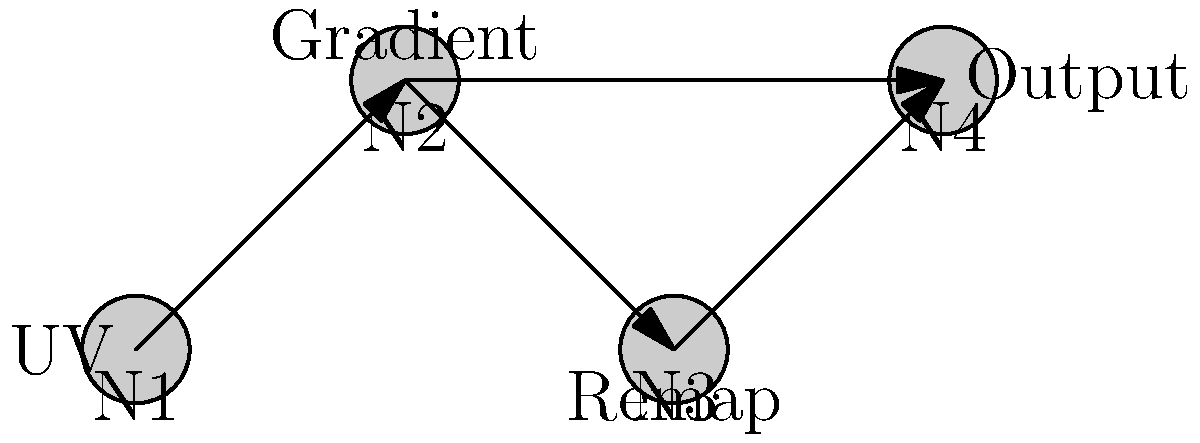In the shader graph shown above, which node configuration would be most suitable for creating a radial gradient effect that transitions smoothly from the center to the edges of a texture? Explain the purpose of each node in achieving this effect. To create a radial gradient effect that transitions smoothly from the center to the edges of a texture, we can use the following node configuration:

1. UV Node (N1):
   - Provides the UV coordinates of the texture.
   - Essential for determining the position of each pixel relative to the texture space.

2. Gradient Node (N2):
   - Takes the UV coordinates as input.
   - Calculates the distance of each pixel from the center of the texture.
   - For a radial gradient, we would use the following formula:
     $$distance = \sqrt{(UV.x - 0.5)^2 + (UV.y - 0.5)^2}$$
   - This creates a circular gradient pattern.

3. Remap Node (N3):
   - Takes the output from the Gradient node.
   - Remaps the distance values to a desired range, typically [0, 1].
   - The remapping is crucial because the raw distance values might exceed 1 at the corners of the texture.
   - We can use the following formula:
     $$remappedValue = saturate(distance * 2)$$
   - This ensures a smooth transition from the center (0) to the edges (1).

4. Output Node (N4):
   - Takes the remapped values.
   - Can be connected to various shader properties like color or opacity.
   - For a basic radial gradient, we might use it directly for the alpha channel or as a factor for color lerping.

This configuration allows for a smooth radial gradient that starts from the center of the texture (where the remapped value is 0) and gradually transitions to the edges (where the remapped value is 1). The Remap node is particularly important as it ensures that the gradient covers the entire texture evenly, preventing any abrupt cutoffs at the corners.
Answer: UV → Gradient (distance calculation) → Remap (value adjustment) → Output 